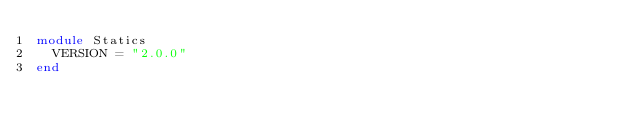<code> <loc_0><loc_0><loc_500><loc_500><_Ruby_>module Statics
  VERSION = "2.0.0"
end
</code> 